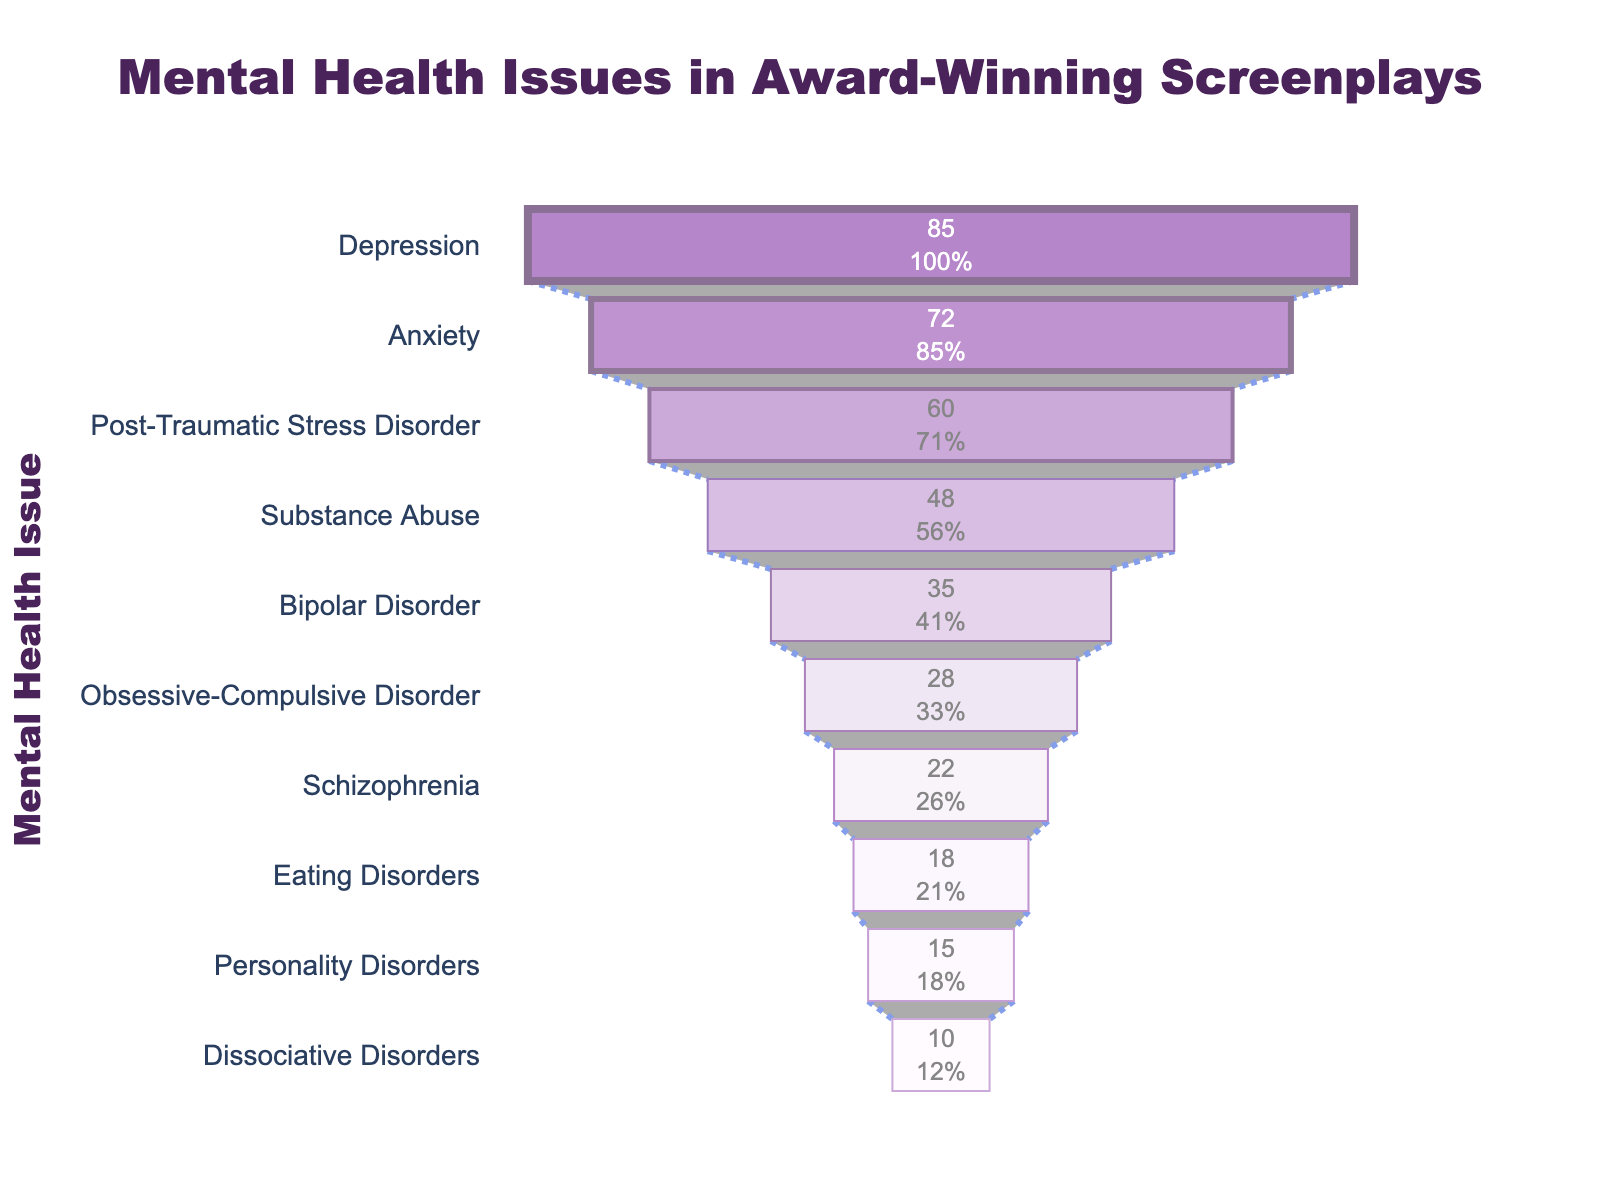What's the title of the figure? The title is located at the top center of the figure, and it clearly states the subject of the plot.
Answer: "Mental Health Issues in Award-Winning Screenplays" Which mental health issue is most frequently portrayed in the award-winning screenplays? The category with the highest frequency bar in the funnel chart is the most frequent.
Answer: Depression How many mental health issues are listed in the figure? Count the number of different categories in the vertical axis of the funnel chart, from top to bottom.
Answer: 10 What percentage of the initial value does Anxiety represent? Refer to the text inside the bar for Anxiety. Anxiety's text includes both its value and the percentage of the initial frequency, which is the frequency for Depression.
Answer: 84.71% What are the two least frequently portrayed mental health issues? Identify the categories with the two smallest bars at the bottom of the funnel chart.
Answer: Dissociative Disorders and Personality Disorders What is the combined frequency of Depression and Anxiety? Add the frequency values of Depression and Anxiety. Depression has 85, and Anxiety has 72. So, 85 + 72.
Answer: 157 How much more frequently is Depression portrayed compared to Personality Disorders? Subtract the frequency of Personality Disorders from the frequency of Depression. Depression has 85, and Personality Disorders have 15. So, 85 - 15.
Answer: 70 Which mental health issue has a frequency closest to but not exceeding 50? Identify the bar whose frequency is closest to 50 without exceeding it. Substance Abuse has a frequency of 48, which is the closest to but not exceeding 50.
Answer: Substance Abuse How does the frequency of Eating Disorders compare with Bipolar Disorder? Compare the lengths of the bars for Eating Disorders and Bipolar Disorder. Eating Disorders has 18, and Bipolar Disorder has 35. Therefore, Bipolar Disorder is more frequent.
Answer: Bipolar Disorder is more frequent What is the relative decrease in frequency from Post-Traumatic Stress Disorder to Substance Abuse? Calculate the difference in their frequencies and divide by the frequency of Post-Traumatic Stress Disorder. PTSD has 60, and Substance Abuse has 48. So, (60 - 48) / 60.
Answer: 0.2 (20%) 